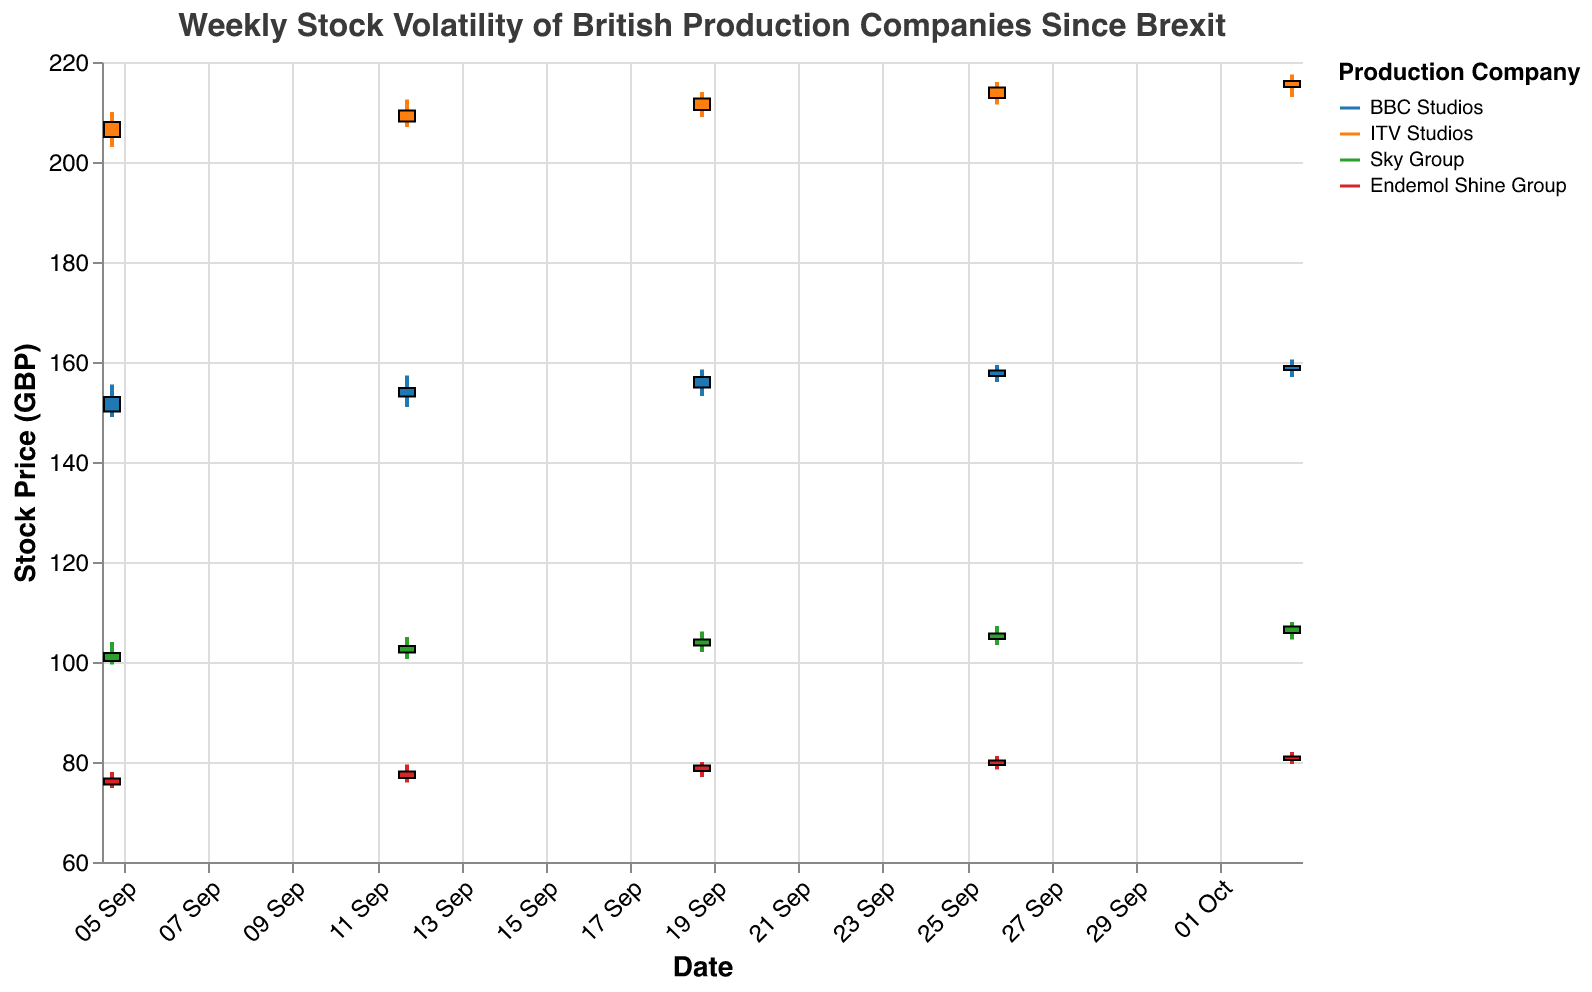What is the title of the figure? The figure's title is prominently placed at the top and states, "Weekly Stock Volatility of British Production Companies Since Brexit".
Answer: Weekly Stock Volatility of British Production Companies Since Brexit Which company's stock had the highest closing price on October 3rd, 2022? By looking at the closing prices for October 3rd, 2022, ITV Studios had the highest closing price at 216.20 GBP.
Answer: ITV Studios How many companies are represented in the figure? The color legend on the right side of the plot lists four different companies: BBC Studios, ITV Studios, Sky Group, and Endemol Shine Group.
Answer: 4 What's the average closing price of Sky Group over the given period? The closing prices of Sky Group from September 5th to October 3rd, 2022, are 101.80, 103.20, 104.50, 105.70, and 107.10. Summing these gives 522.30. Dividing by 5 gives an average of 104.46.
Answer: 104.46 Which company showed the largest difference between its highest and lowest stock price on September 5th, 2022? The differences are BBC Studios (6.5), ITV Studios (7), Sky Group (4.5), and Endemol Shine Group (3.2). The largest difference is by ITV Studios.
Answer: ITV Studios Did Endemol Shine Group's stock price increase or decrease overall from September 5th to October 3rd, 2022? Comparing the opening price on September 5th (75.50) with the closing price on October 3rd (81.10), Endemol Shine Group's stock price increased overall.
Answer: Increased Which company had the most significant increase in closing price between September 12th and September 19th, 2022? The companies' closing price differences: BBC Studios (2.20), ITV Studios (2.40), Sky Group (1.30), Endemol Shine Group (1.20). ITV Studios had the biggest increase (2.40).
Answer: ITV Studios Which company had the lowest opening stock price on October 3rd, 2022? The opening prices on October 3rd are listed and Endemol Shine Group has the lowest opening price at 80.40 GBP.
Answer: Endemol Shine Group Is there a general trend in the closing prices of BBC Studios over the weeks shown in the figure? The closing prices of BBC Studios from September 5th to October 3rd show an increasing trend: 153.00, 154.80, 157.00, 158.30, 159.20.
Answer: Increasing trend What is the range of ITV Studios' stock price on September 26th, 2022? The range is the difference between the high (216.00) and low (211.50) prices on September 26th, which is 4.50 GBP.
Answer: 4.50 GBP 